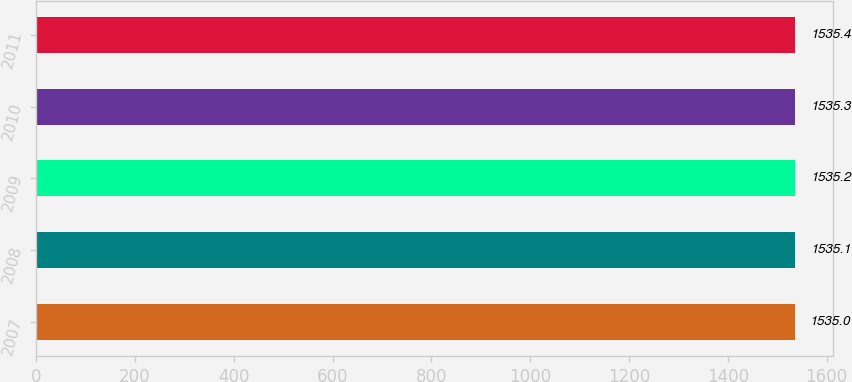Convert chart to OTSL. <chart><loc_0><loc_0><loc_500><loc_500><bar_chart><fcel>2007<fcel>2008<fcel>2009<fcel>2010<fcel>2011<nl><fcel>1535<fcel>1535.1<fcel>1535.2<fcel>1535.3<fcel>1535.4<nl></chart> 